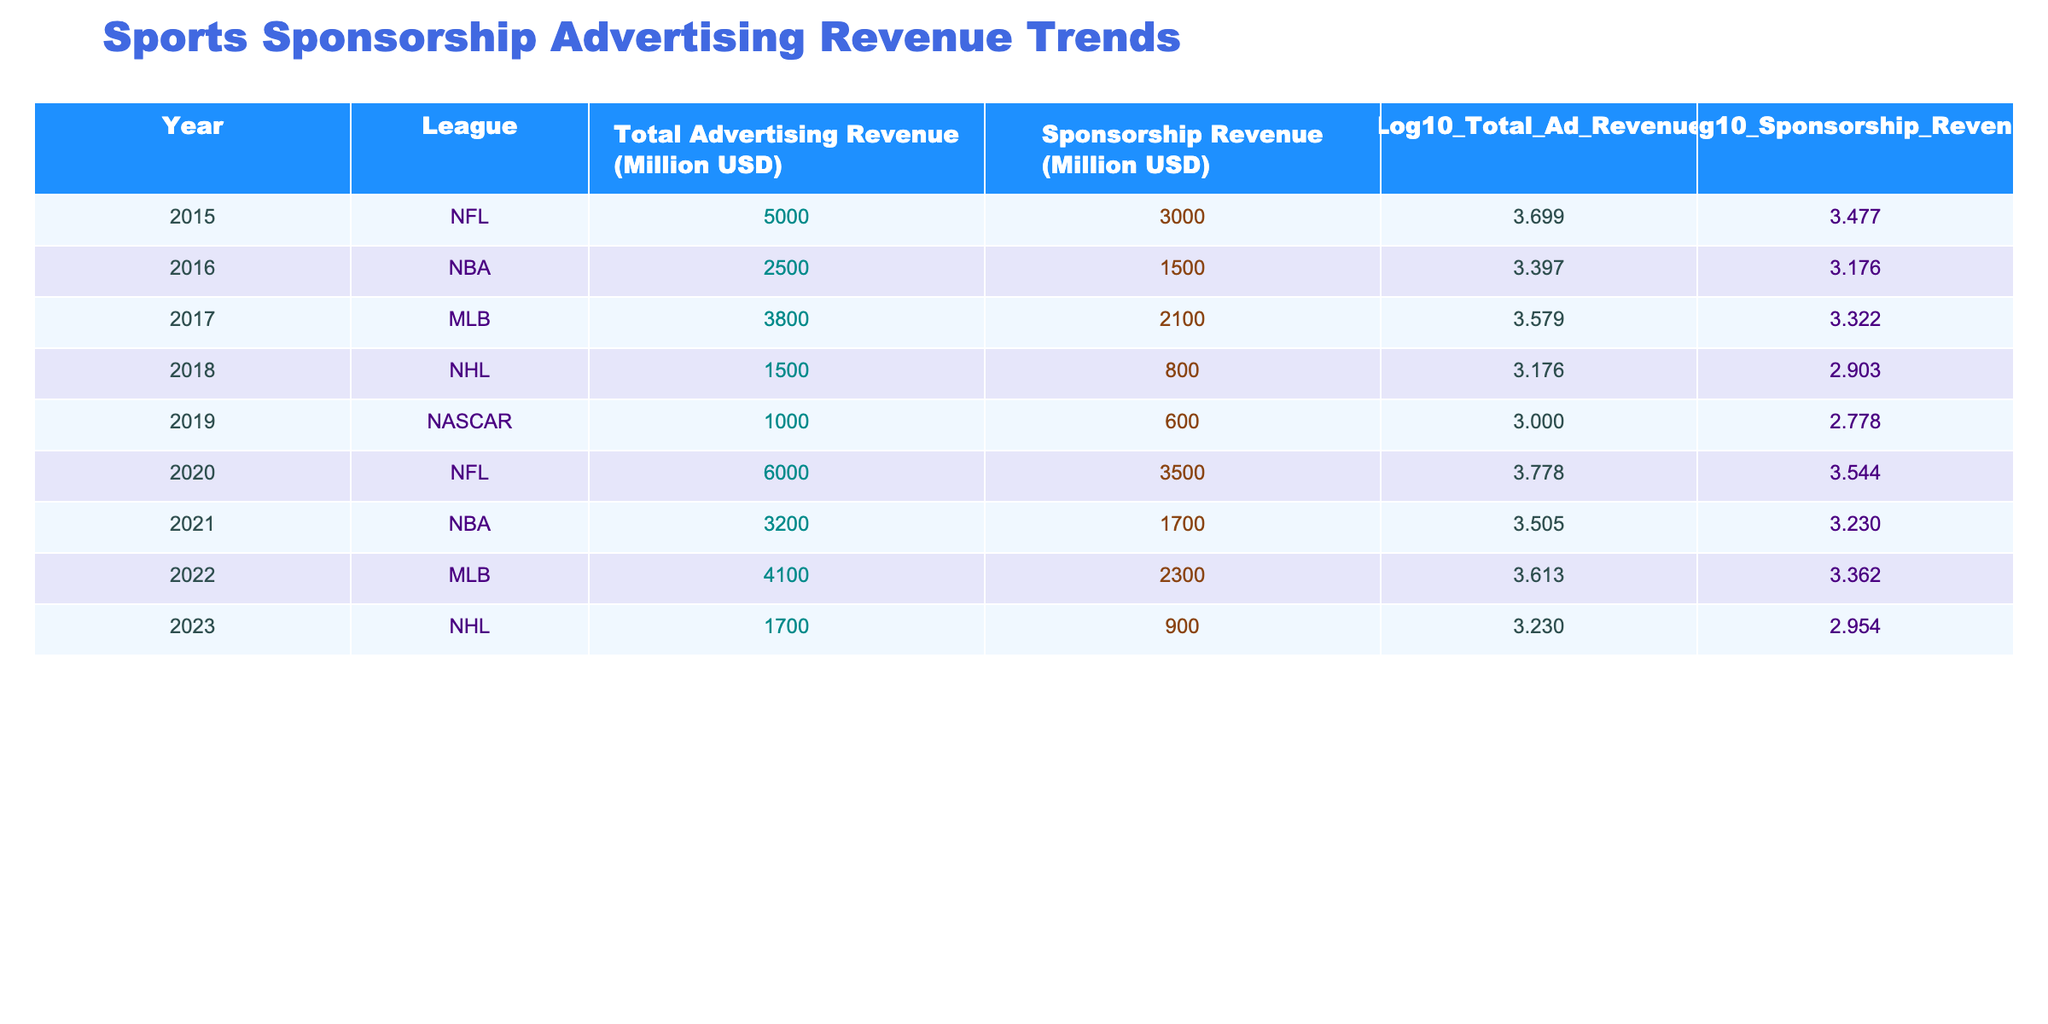What was the total advertising revenue for the NFL in 2020? Referring to the table, the row for the NFL in the year 2020 shows a total advertising revenue of 6000 million USD.
Answer: 6000 million USD Which league had the highest sponsorship revenue in 2022? Looking at the table, the MLB in 2022 had the highest sponsorship revenue of 2300 million USD.
Answer: MLB What is the difference between the total advertising revenue of the NBA in 2016 and 2021? The total advertising revenue for the NBA in 2016 was 2500 million USD, and in 2021 it was 3200 million USD. The difference is 3200 - 2500 = 700 million USD.
Answer: 700 million USD Is the total advertising revenue for NASCAR in 2019 greater than 1000 million USD? The table shows the NASCAR total advertising revenue in 2019 was exactly 1000 million USD, so it is not greater than that amount.
Answer: No What was the average total advertising revenue across all leagues from 2015 to 2023? The total advertising revenues are: 5000 (2015) + 2500 (2016) + 3800 (2017) + 1500 (2018) + 1000 (2019) + 6000 (2020) + 3200 (2021) + 4100 (2022) + 1700 (2023) = 22800 million USD. There are 9 years, so the average is 22800 / 9 ≈ 2533.33 million USD.
Answer: 2533.33 million USD In which year did the NHL have the lowest sponsorship revenue? By examining the table, the NHL had a sponsorship revenue of 800 million USD in 2018, which is lower than the other years listed in the table.
Answer: 2018 What is the total sponsorship revenue for the NFL across both years listed? The NFL had sponsorship revenues of 3000 million USD in 2015 and 3500 million USD in 2020. The total sponsorship revenue is 3000 + 3500 = 6500 million USD.
Answer: 6500 million USD Was the logarithmic value of total advertising revenue for the MLB in 2022 higher than its logarithmic value in 2017? The logarithmic value of total advertising revenue for the MLB in 2022 is 3.613, while in 2017 it is 3.579. Since 3.613 is greater than 3.579, the statement is true.
Answer: Yes How much did sponsorship revenue increase for the NBA from 2016 to 2021? The sponsorship revenue for the NBA in 2016 was 1500 million USD and in 2021 it was 1700 million USD. The increase is 1700 - 1500 = 200 million USD.
Answer: 200 million USD 